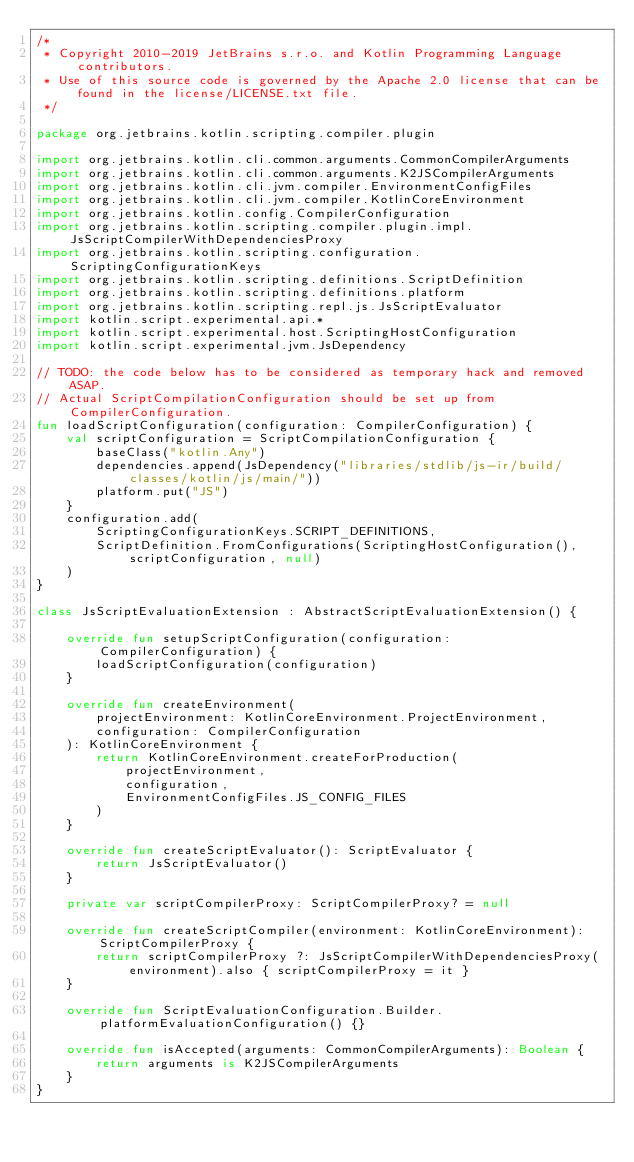Convert code to text. <code><loc_0><loc_0><loc_500><loc_500><_Kotlin_>/*
 * Copyright 2010-2019 JetBrains s.r.o. and Kotlin Programming Language contributors.
 * Use of this source code is governed by the Apache 2.0 license that can be found in the license/LICENSE.txt file.
 */

package org.jetbrains.kotlin.scripting.compiler.plugin

import org.jetbrains.kotlin.cli.common.arguments.CommonCompilerArguments
import org.jetbrains.kotlin.cli.common.arguments.K2JSCompilerArguments
import org.jetbrains.kotlin.cli.jvm.compiler.EnvironmentConfigFiles
import org.jetbrains.kotlin.cli.jvm.compiler.KotlinCoreEnvironment
import org.jetbrains.kotlin.config.CompilerConfiguration
import org.jetbrains.kotlin.scripting.compiler.plugin.impl.JsScriptCompilerWithDependenciesProxy
import org.jetbrains.kotlin.scripting.configuration.ScriptingConfigurationKeys
import org.jetbrains.kotlin.scripting.definitions.ScriptDefinition
import org.jetbrains.kotlin.scripting.definitions.platform
import org.jetbrains.kotlin.scripting.repl.js.JsScriptEvaluator
import kotlin.script.experimental.api.*
import kotlin.script.experimental.host.ScriptingHostConfiguration
import kotlin.script.experimental.jvm.JsDependency

// TODO: the code below has to be considered as temporary hack and removed ASAP.
// Actual ScriptCompilationConfiguration should be set up from CompilerConfiguration.
fun loadScriptConfiguration(configuration: CompilerConfiguration) {
    val scriptConfiguration = ScriptCompilationConfiguration {
        baseClass("kotlin.Any")
        dependencies.append(JsDependency("libraries/stdlib/js-ir/build/classes/kotlin/js/main/"))
        platform.put("JS")
    }
    configuration.add(
        ScriptingConfigurationKeys.SCRIPT_DEFINITIONS,
        ScriptDefinition.FromConfigurations(ScriptingHostConfiguration(), scriptConfiguration, null)
    )
}

class JsScriptEvaluationExtension : AbstractScriptEvaluationExtension() {

    override fun setupScriptConfiguration(configuration: CompilerConfiguration) {
        loadScriptConfiguration(configuration)
    }

    override fun createEnvironment(
        projectEnvironment: KotlinCoreEnvironment.ProjectEnvironment,
        configuration: CompilerConfiguration
    ): KotlinCoreEnvironment {
        return KotlinCoreEnvironment.createForProduction(
            projectEnvironment,
            configuration,
            EnvironmentConfigFiles.JS_CONFIG_FILES
        )
    }

    override fun createScriptEvaluator(): ScriptEvaluator {
        return JsScriptEvaluator()
    }

    private var scriptCompilerProxy: ScriptCompilerProxy? = null

    override fun createScriptCompiler(environment: KotlinCoreEnvironment): ScriptCompilerProxy {
        return scriptCompilerProxy ?: JsScriptCompilerWithDependenciesProxy(environment).also { scriptCompilerProxy = it }
    }

    override fun ScriptEvaluationConfiguration.Builder.platformEvaluationConfiguration() {}

    override fun isAccepted(arguments: CommonCompilerArguments): Boolean {
        return arguments is K2JSCompilerArguments
    }
}
</code> 